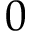<formula> <loc_0><loc_0><loc_500><loc_500>0</formula> 